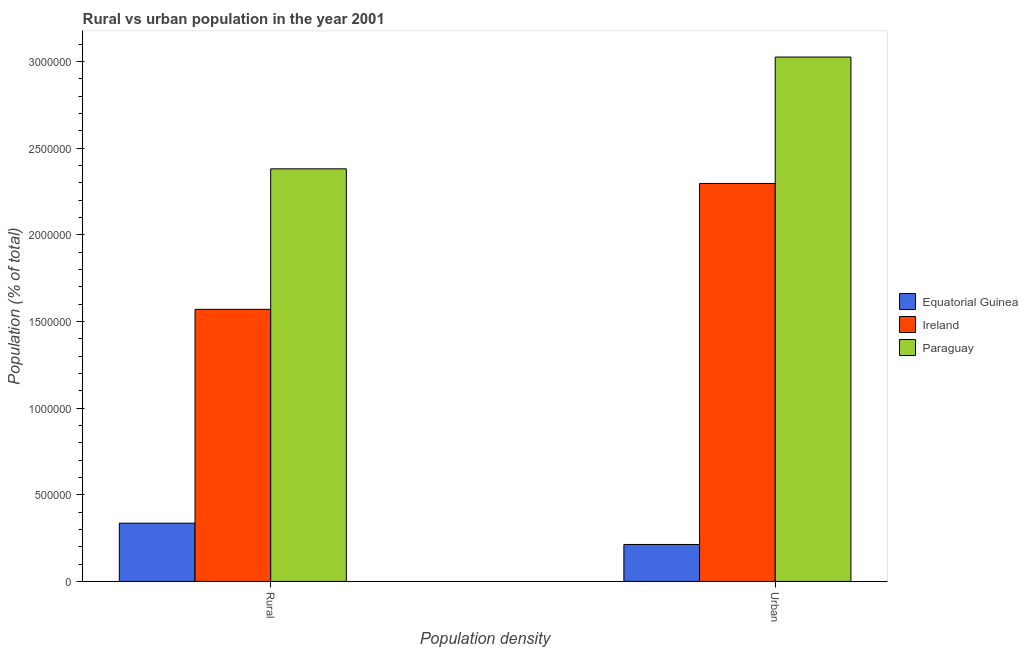How many different coloured bars are there?
Ensure brevity in your answer.  3. How many groups of bars are there?
Provide a short and direct response. 2. What is the label of the 2nd group of bars from the left?
Give a very brief answer. Urban. What is the rural population density in Paraguay?
Ensure brevity in your answer.  2.38e+06. Across all countries, what is the maximum urban population density?
Your response must be concise. 3.03e+06. Across all countries, what is the minimum urban population density?
Your answer should be compact. 2.13e+05. In which country was the urban population density maximum?
Offer a terse response. Paraguay. In which country was the urban population density minimum?
Keep it short and to the point. Equatorial Guinea. What is the total rural population density in the graph?
Offer a very short reply. 4.29e+06. What is the difference between the rural population density in Equatorial Guinea and that in Paraguay?
Provide a short and direct response. -2.04e+06. What is the difference between the rural population density in Equatorial Guinea and the urban population density in Paraguay?
Ensure brevity in your answer.  -2.69e+06. What is the average rural population density per country?
Your answer should be very brief. 1.43e+06. What is the difference between the rural population density and urban population density in Equatorial Guinea?
Provide a succinct answer. 1.23e+05. What is the ratio of the rural population density in Equatorial Guinea to that in Ireland?
Provide a short and direct response. 0.21. In how many countries, is the urban population density greater than the average urban population density taken over all countries?
Keep it short and to the point. 2. What does the 3rd bar from the left in Rural represents?
Your answer should be compact. Paraguay. What does the 3rd bar from the right in Rural represents?
Provide a succinct answer. Equatorial Guinea. How many bars are there?
Your answer should be compact. 6. Are the values on the major ticks of Y-axis written in scientific E-notation?
Make the answer very short. No. Does the graph contain any zero values?
Your answer should be compact. No. Where does the legend appear in the graph?
Your response must be concise. Center right. How many legend labels are there?
Offer a very short reply. 3. What is the title of the graph?
Keep it short and to the point. Rural vs urban population in the year 2001. Does "Mongolia" appear as one of the legend labels in the graph?
Provide a short and direct response. No. What is the label or title of the X-axis?
Ensure brevity in your answer.  Population density. What is the label or title of the Y-axis?
Offer a very short reply. Population (% of total). What is the Population (% of total) in Equatorial Guinea in Rural?
Your response must be concise. 3.36e+05. What is the Population (% of total) of Ireland in Rural?
Keep it short and to the point. 1.57e+06. What is the Population (% of total) of Paraguay in Rural?
Ensure brevity in your answer.  2.38e+06. What is the Population (% of total) in Equatorial Guinea in Urban?
Offer a terse response. 2.13e+05. What is the Population (% of total) in Ireland in Urban?
Give a very brief answer. 2.30e+06. What is the Population (% of total) of Paraguay in Urban?
Offer a very short reply. 3.03e+06. Across all Population density, what is the maximum Population (% of total) in Equatorial Guinea?
Offer a very short reply. 3.36e+05. Across all Population density, what is the maximum Population (% of total) of Ireland?
Provide a succinct answer. 2.30e+06. Across all Population density, what is the maximum Population (% of total) in Paraguay?
Provide a succinct answer. 3.03e+06. Across all Population density, what is the minimum Population (% of total) of Equatorial Guinea?
Your answer should be compact. 2.13e+05. Across all Population density, what is the minimum Population (% of total) of Ireland?
Give a very brief answer. 1.57e+06. Across all Population density, what is the minimum Population (% of total) of Paraguay?
Your answer should be very brief. 2.38e+06. What is the total Population (% of total) of Equatorial Guinea in the graph?
Your answer should be very brief. 5.49e+05. What is the total Population (% of total) of Ireland in the graph?
Give a very brief answer. 3.87e+06. What is the total Population (% of total) of Paraguay in the graph?
Ensure brevity in your answer.  5.41e+06. What is the difference between the Population (% of total) in Equatorial Guinea in Rural and that in Urban?
Your answer should be very brief. 1.23e+05. What is the difference between the Population (% of total) in Ireland in Rural and that in Urban?
Your response must be concise. -7.26e+05. What is the difference between the Population (% of total) in Paraguay in Rural and that in Urban?
Provide a succinct answer. -6.45e+05. What is the difference between the Population (% of total) of Equatorial Guinea in Rural and the Population (% of total) of Ireland in Urban?
Make the answer very short. -1.96e+06. What is the difference between the Population (% of total) in Equatorial Guinea in Rural and the Population (% of total) in Paraguay in Urban?
Ensure brevity in your answer.  -2.69e+06. What is the difference between the Population (% of total) in Ireland in Rural and the Population (% of total) in Paraguay in Urban?
Provide a succinct answer. -1.46e+06. What is the average Population (% of total) of Equatorial Guinea per Population density?
Offer a very short reply. 2.75e+05. What is the average Population (% of total) in Ireland per Population density?
Provide a short and direct response. 1.93e+06. What is the average Population (% of total) of Paraguay per Population density?
Your response must be concise. 2.70e+06. What is the difference between the Population (% of total) in Equatorial Guinea and Population (% of total) in Ireland in Rural?
Give a very brief answer. -1.23e+06. What is the difference between the Population (% of total) of Equatorial Guinea and Population (% of total) of Paraguay in Rural?
Offer a very short reply. -2.04e+06. What is the difference between the Population (% of total) of Ireland and Population (% of total) of Paraguay in Rural?
Ensure brevity in your answer.  -8.11e+05. What is the difference between the Population (% of total) of Equatorial Guinea and Population (% of total) of Ireland in Urban?
Provide a short and direct response. -2.08e+06. What is the difference between the Population (% of total) of Equatorial Guinea and Population (% of total) of Paraguay in Urban?
Ensure brevity in your answer.  -2.81e+06. What is the difference between the Population (% of total) of Ireland and Population (% of total) of Paraguay in Urban?
Your response must be concise. -7.30e+05. What is the ratio of the Population (% of total) in Equatorial Guinea in Rural to that in Urban?
Give a very brief answer. 1.58. What is the ratio of the Population (% of total) in Ireland in Rural to that in Urban?
Make the answer very short. 0.68. What is the ratio of the Population (% of total) in Paraguay in Rural to that in Urban?
Offer a terse response. 0.79. What is the difference between the highest and the second highest Population (% of total) of Equatorial Guinea?
Offer a terse response. 1.23e+05. What is the difference between the highest and the second highest Population (% of total) in Ireland?
Provide a succinct answer. 7.26e+05. What is the difference between the highest and the second highest Population (% of total) of Paraguay?
Your answer should be very brief. 6.45e+05. What is the difference between the highest and the lowest Population (% of total) in Equatorial Guinea?
Give a very brief answer. 1.23e+05. What is the difference between the highest and the lowest Population (% of total) of Ireland?
Provide a succinct answer. 7.26e+05. What is the difference between the highest and the lowest Population (% of total) of Paraguay?
Make the answer very short. 6.45e+05. 